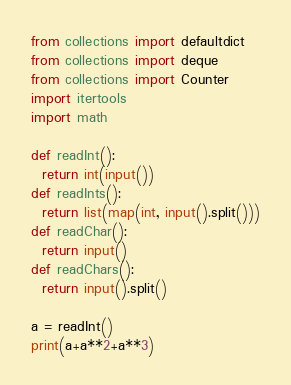Convert code to text. <code><loc_0><loc_0><loc_500><loc_500><_Python_>from collections import defaultdict
from collections import deque
from collections import Counter
import itertools
import math

def readInt():
  return int(input())
def readInts():
  return list(map(int, input().split()))
def readChar():
  return input()
def readChars():
  return input().split()

a = readInt()
print(a+a**2+a**3)</code> 